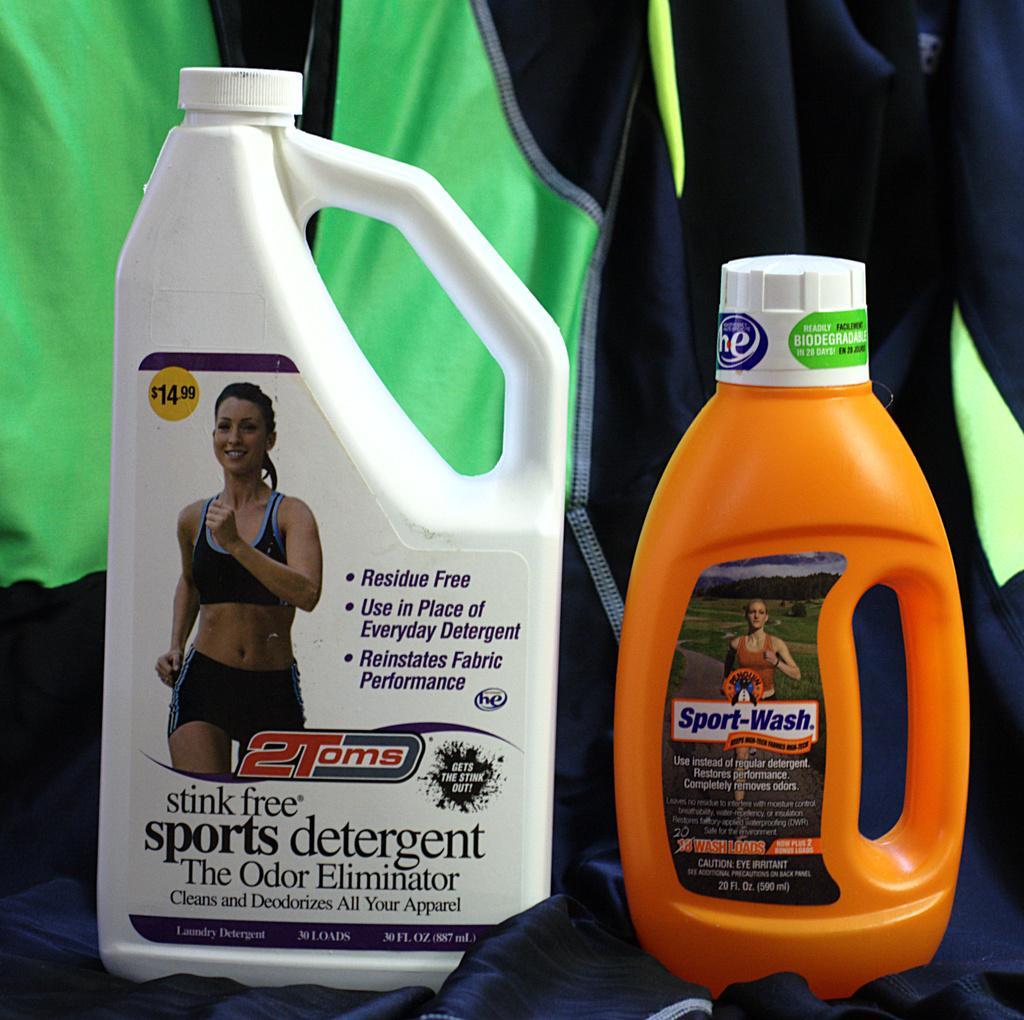Describe this image in one or two sentences. In this picture we can see bottles on a black cloth and in the background we can see a green cloth. 